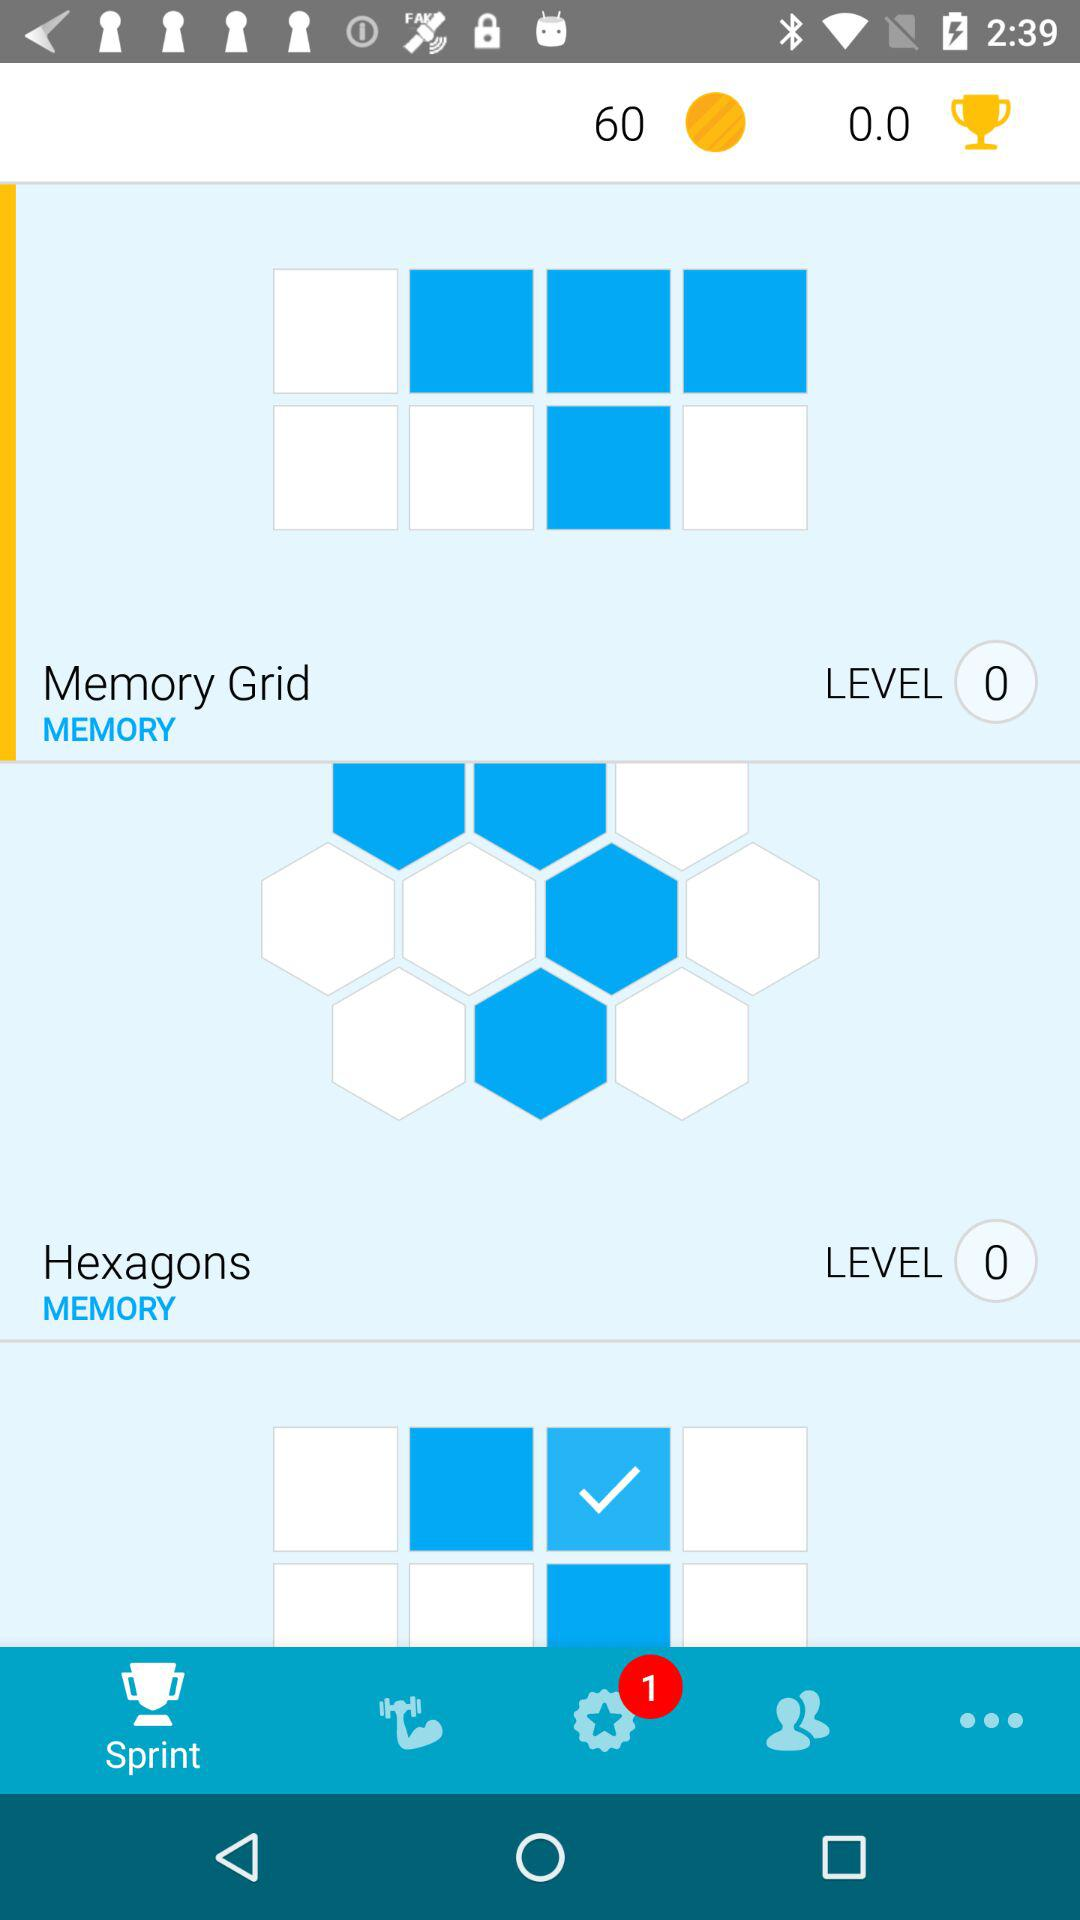Which tab is selected? The selected tab is "Sprint". 